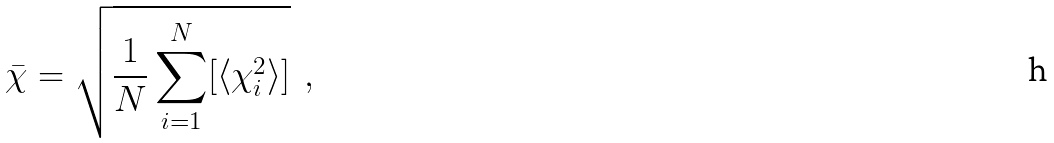<formula> <loc_0><loc_0><loc_500><loc_500>\bar { \chi } = \sqrt { \frac { 1 } { N } \sum _ { i = 1 } ^ { N } [ \langle \chi _ { i } ^ { 2 } \rangle ] } \ \ ,</formula> 